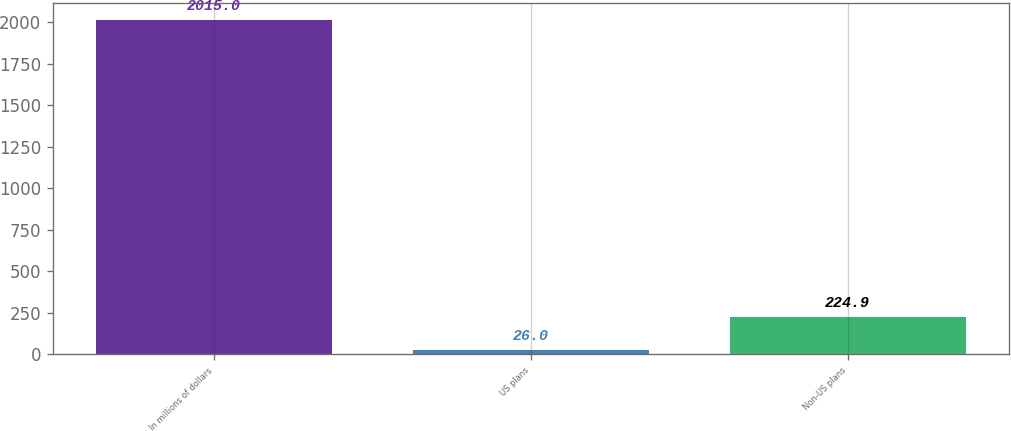<chart> <loc_0><loc_0><loc_500><loc_500><bar_chart><fcel>In millions of dollars<fcel>US plans<fcel>Non-US plans<nl><fcel>2015<fcel>26<fcel>224.9<nl></chart> 